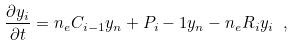Convert formula to latex. <formula><loc_0><loc_0><loc_500><loc_500>\frac { \partial y _ { i } } { \partial t } = n _ { e } C _ { i - 1 } y _ { n } + P _ { i } - 1 y _ { n } - n _ { e } R _ { i } y _ { i } \ ,</formula> 